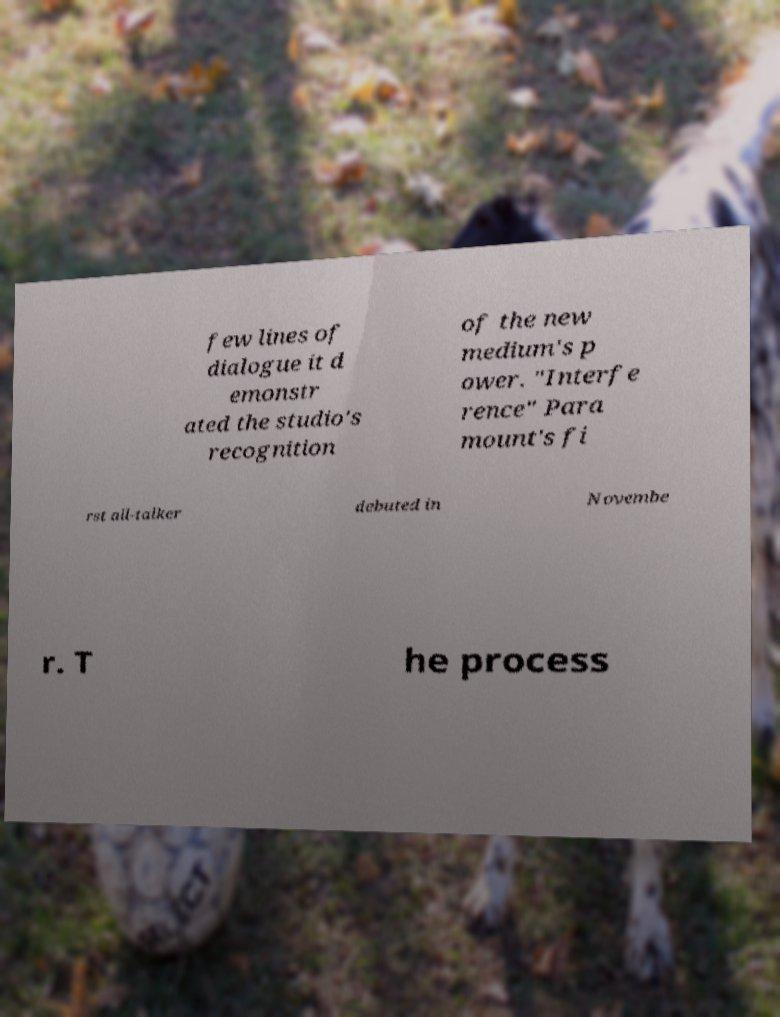Please identify and transcribe the text found in this image. few lines of dialogue it d emonstr ated the studio's recognition of the new medium's p ower. "Interfe rence" Para mount's fi rst all-talker debuted in Novembe r. T he process 